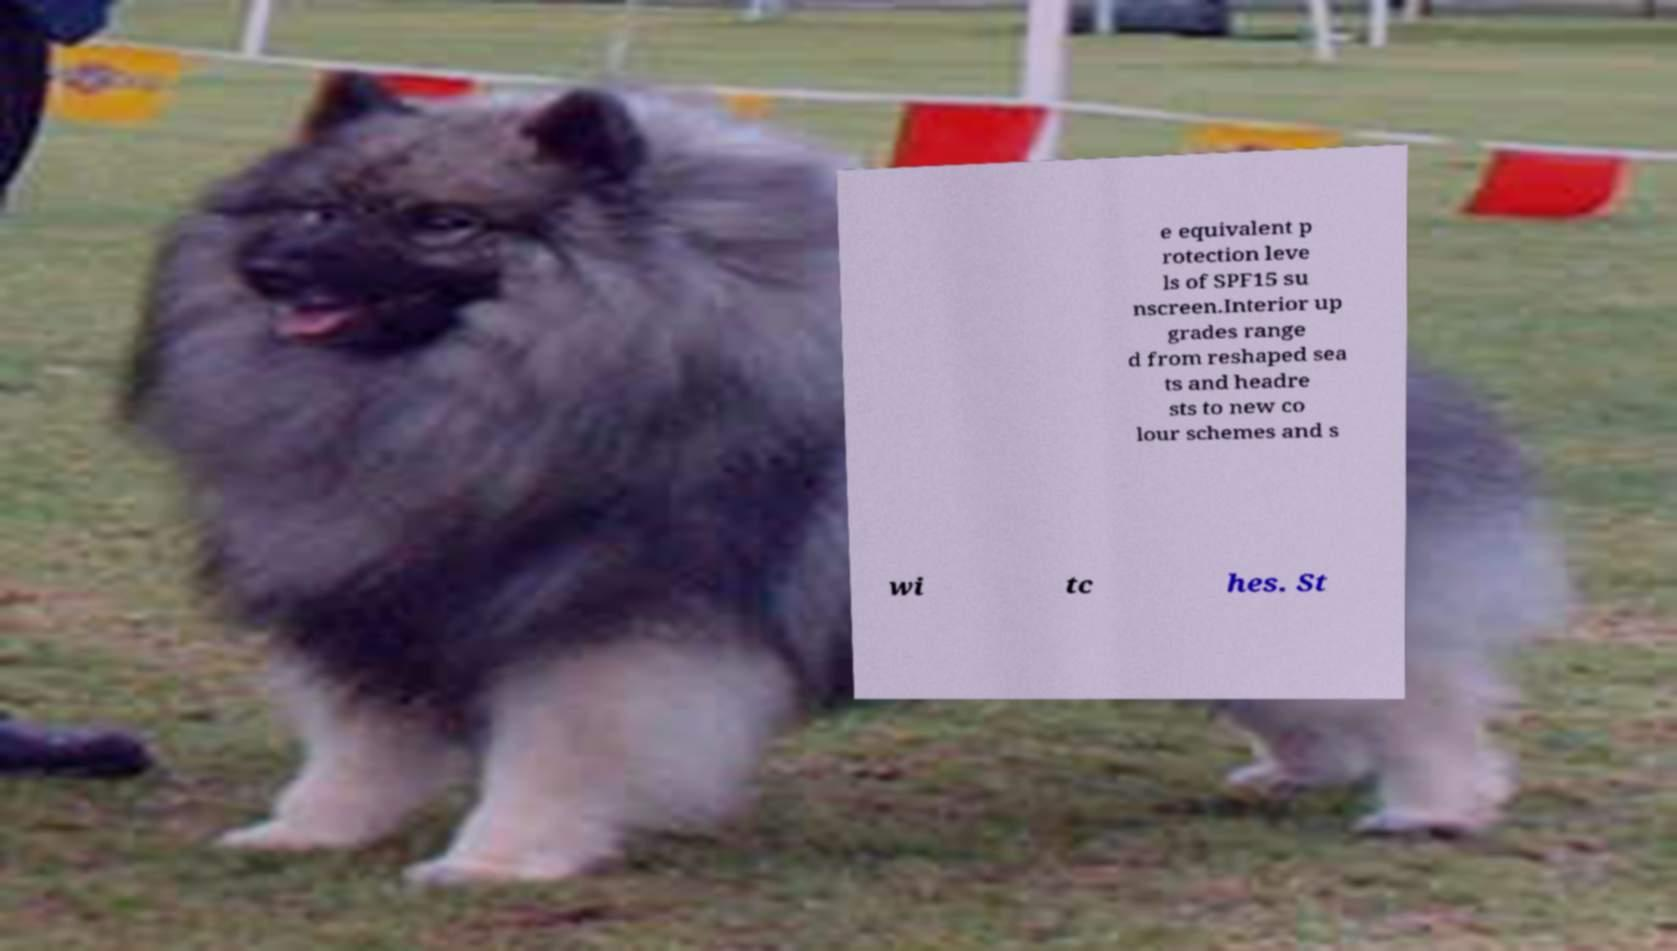Please identify and transcribe the text found in this image. e equivalent p rotection leve ls of SPF15 su nscreen.Interior up grades range d from reshaped sea ts and headre sts to new co lour schemes and s wi tc hes. St 